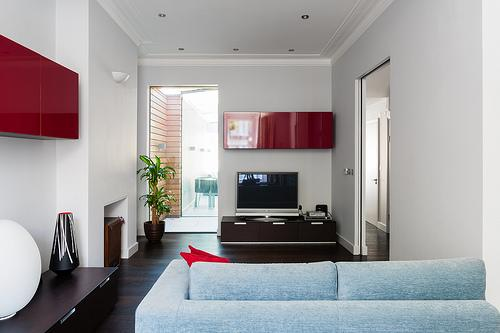Identify the types of doorways present in the living room. An open doorway to the hall, a doorway to a patio, and a doorway in the living room. Describe the TV setup in the living room. There is a flat screen TV on a brown wood stand with red cabinets above it, placed next to a set of switches on the wall. List the different lighting sources in the living room. A row of lights in the ceiling, a light sconce, a white light on the wall, and switches on the wall. Describe the overall scene shown in the image. A small living room with a light blue couch, red pillows, red cabinets, a flat screen tv on a brown wood stand, decorative plants, and various lighting sources. What color are the cabinets in the room and where are they located? The cabinets are red and located above the flat screen TV on the wall. Provide a brief summary of the main items in the living room. A light blue couch with red pillows, a brown wood TV stand with a flat screen TV, red cabinets, and decorative plants and lights. Where is the black vase located in the image? The black vase is located on a table in the living room. How many red pillows are on the couch? There are 5 red pillows on the light blue couch. Mention any instances of plants in the living room. There is a large house plant by the wall, a decorative plant, and a plant decoration in the living room. What color is the couch and what is placed on it? The couch is light blue and it has red pillows on it. Elaborate on the style of decoration used in the living room in the image. There is a plant decoration, a decorative vase in black, and red pillows on the couch. Identify the color of the cabinets present in the image. The cabinets are red. Determine whether a doorway to a patio is present or not. Yes, there is a doorway to a patio. Connect the presence of red pillows with the color of the couch in the image. There are red pillows on a light blue couch. Mention any activities happening in the image. No activities as there are no people in the image. Describe the color and location of the vase in the living room. There's a black vase on the table in the living room. Image depicts an indoor or outdoor setting? Indoor What type of electronic device can be found in the image? A flat screen TV What color is the pillow situated on the couch in the image? Red According to the image, identify the type of plant present in the living room. A large house plant by the wall. Describe the type of table found in the image. A dark brown table next to the wall. What type of door is present in the living room according to the image? An open doorway to the hall. Describe the location and color of the door in this image. There's a white door down the hallway. Describe the type of light fixture mounted on the wall in the image. This is a white light sconce on the wall. Choose the correct statement regarding the couch: (a) The couch is green, (b) The couch is yellow, (c) The couch is blue, (d) The couch is orange. (c) The couch is blue Is there any text displayed on the TV screen in the image? No visible text on the TV screen. Provide a brief caption that describes the featured living room in the image. The shot of a small living room with a blue couch, red pillows, and a flat screen TV. Is there a ceiling light fixture in the living room? Yes, there is a row of lights in the ceiling. 